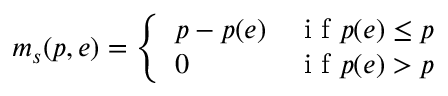<formula> <loc_0><loc_0><loc_500><loc_500>m _ { s } ( p , e ) = \left \{ \begin{array} { l l } { p - p ( e ) } & { i f p ( e ) \leq p } \\ { 0 } & { i f p ( e ) > p } \end{array}</formula> 